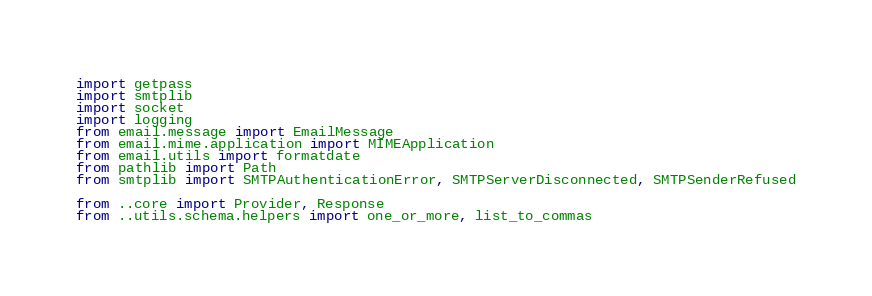<code> <loc_0><loc_0><loc_500><loc_500><_Python_>import getpass
import smtplib
import socket
import logging
from email.message import EmailMessage
from email.mime.application import MIMEApplication
from email.utils import formatdate
from pathlib import Path
from smtplib import SMTPAuthenticationError, SMTPServerDisconnected, SMTPSenderRefused

from ..core import Provider, Response
from ..utils.schema.helpers import one_or_more, list_to_commas
</code> 